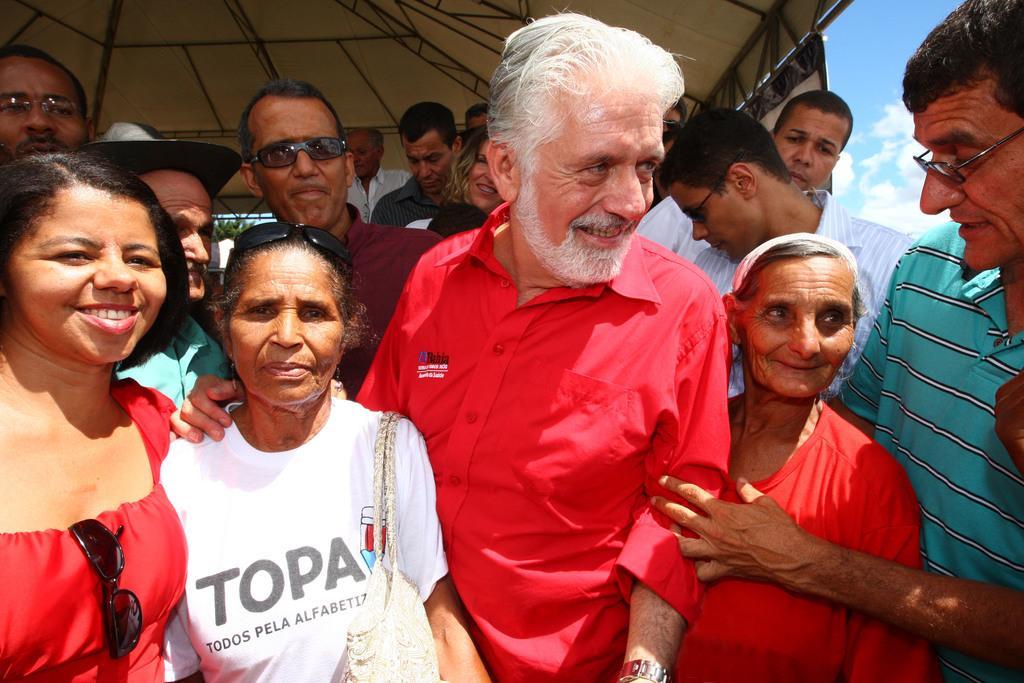Describe this image in one or two sentences. In this image, we can see people and some are wearing glasses, one of them is wearing a bag. At the top, there is a roof and there are clouds in the sky. In the background, there are trees. 